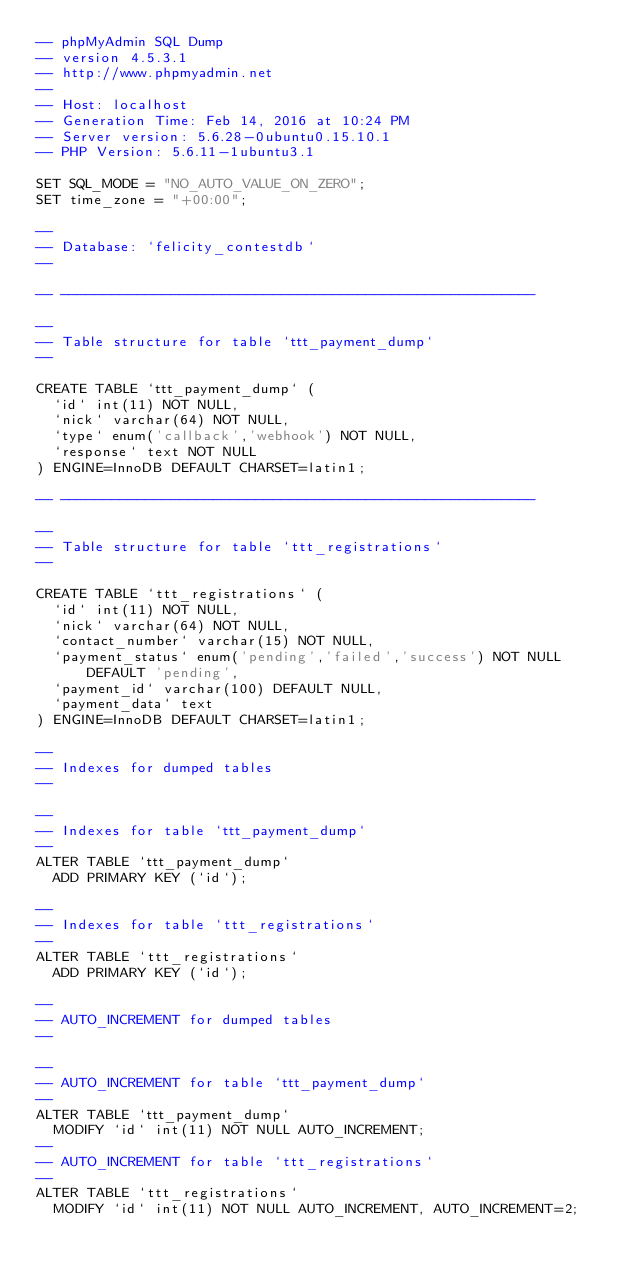<code> <loc_0><loc_0><loc_500><loc_500><_SQL_>-- phpMyAdmin SQL Dump
-- version 4.5.3.1
-- http://www.phpmyadmin.net
--
-- Host: localhost
-- Generation Time: Feb 14, 2016 at 10:24 PM
-- Server version: 5.6.28-0ubuntu0.15.10.1
-- PHP Version: 5.6.11-1ubuntu3.1

SET SQL_MODE = "NO_AUTO_VALUE_ON_ZERO";
SET time_zone = "+00:00";

--
-- Database: `felicity_contestdb`
--

-- --------------------------------------------------------

--
-- Table structure for table `ttt_payment_dump`
--

CREATE TABLE `ttt_payment_dump` (
  `id` int(11) NOT NULL,
  `nick` varchar(64) NOT NULL,
  `type` enum('callback','webhook') NOT NULL,
  `response` text NOT NULL
) ENGINE=InnoDB DEFAULT CHARSET=latin1;

-- --------------------------------------------------------

--
-- Table structure for table `ttt_registrations`
--

CREATE TABLE `ttt_registrations` (
  `id` int(11) NOT NULL,
  `nick` varchar(64) NOT NULL,
  `contact_number` varchar(15) NOT NULL,
  `payment_status` enum('pending','failed','success') NOT NULL DEFAULT 'pending',
  `payment_id` varchar(100) DEFAULT NULL,
  `payment_data` text
) ENGINE=InnoDB DEFAULT CHARSET=latin1;

--
-- Indexes for dumped tables
--

--
-- Indexes for table `ttt_payment_dump`
--
ALTER TABLE `ttt_payment_dump`
  ADD PRIMARY KEY (`id`);

--
-- Indexes for table `ttt_registrations`
--
ALTER TABLE `ttt_registrations`
  ADD PRIMARY KEY (`id`);

--
-- AUTO_INCREMENT for dumped tables
--

--
-- AUTO_INCREMENT for table `ttt_payment_dump`
--
ALTER TABLE `ttt_payment_dump`
  MODIFY `id` int(11) NOT NULL AUTO_INCREMENT;
--
-- AUTO_INCREMENT for table `ttt_registrations`
--
ALTER TABLE `ttt_registrations`
  MODIFY `id` int(11) NOT NULL AUTO_INCREMENT, AUTO_INCREMENT=2;
</code> 